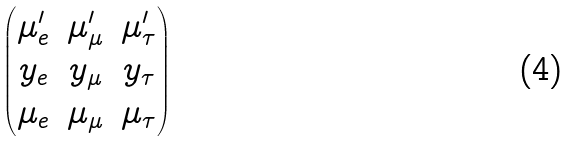Convert formula to latex. <formula><loc_0><loc_0><loc_500><loc_500>\begin{pmatrix} \mu ^ { \prime } _ { e } & \mu ^ { \prime } _ { \mu } & \mu ^ { \prime } _ { \tau } \\ y _ { e } & y _ { \mu } & y _ { \tau } \\ \mu _ { e } & \mu _ { \mu } & \mu _ { \tau } \end{pmatrix}</formula> 